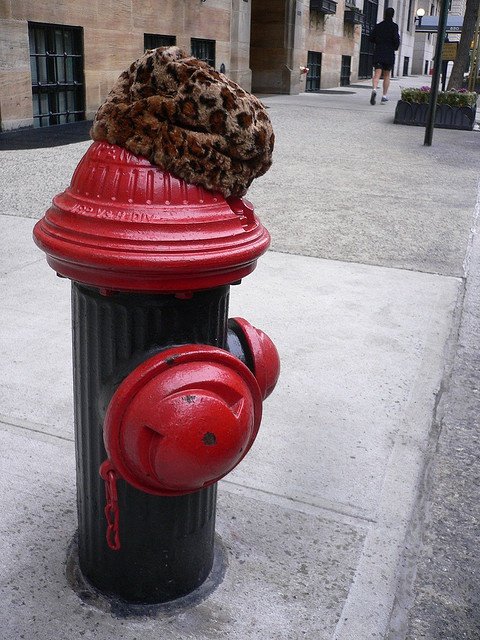Describe the objects in this image and their specific colors. I can see fire hydrant in gray, black, maroon, and brown tones and people in gray, black, and darkgray tones in this image. 